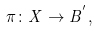<formula> <loc_0><loc_0><loc_500><loc_500>\pi \colon X \to B ^ { ^ { \prime } } ,</formula> 